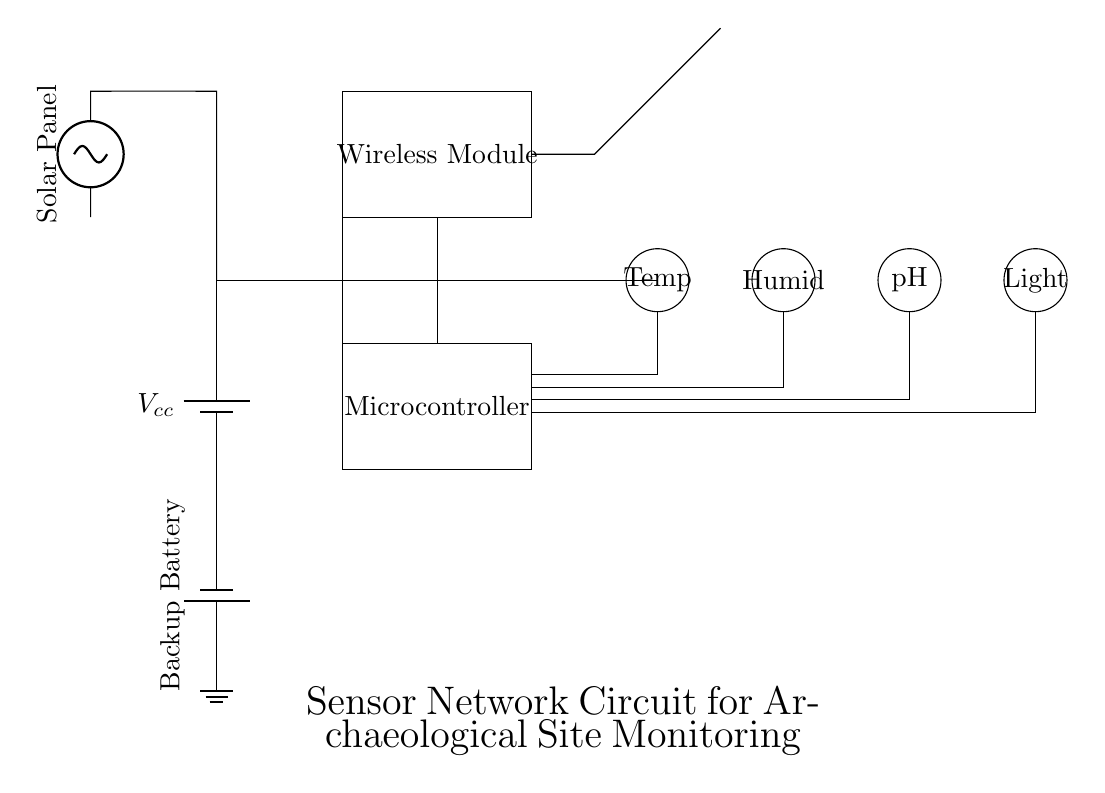What is the main power supply component in this circuit? The main power supply component is a battery, which is denoted as Vcc in the diagram. It provides the necessary voltage to power the circuit.
Answer: battery How many sensors are present in this circuit? The diagram shows four distinct sensors, each represented with a circular symbol — temperature, humidity, pH, and light sensors, thus making a total of four sensors.
Answer: four What is the purpose of the wireless module in this circuit? The wireless module facilitates communication by allowing the device to send data from the sensors to a remote device, making it essential for monitoring environmental conditions without physical connections.
Answer: communication How is the power for this circuit sourced? The circuit source includes a solar panel and a backup battery. The solar panel provides primary power, while the backup battery supports the circuit if solar energy is insufficient.
Answer: solar panel and battery What component connects to the antenna in the circuit? The wireless module connects to the antenna. The diagram shows a line leading from the wireless module to the antenna, indicating this relationship for data transmission.
Answer: wireless module Describe the function of the ground in the circuit. The ground acts as a reference point for the circuit voltage and a return path for electric current, ensuring stability and safety in the circuit operation.
Answer: stability and safety Which component powers the sensors directly? The microcontroller connects directly to the sensors, providing them with the necessary power to operate and report environmental readings.
Answer: microcontroller 